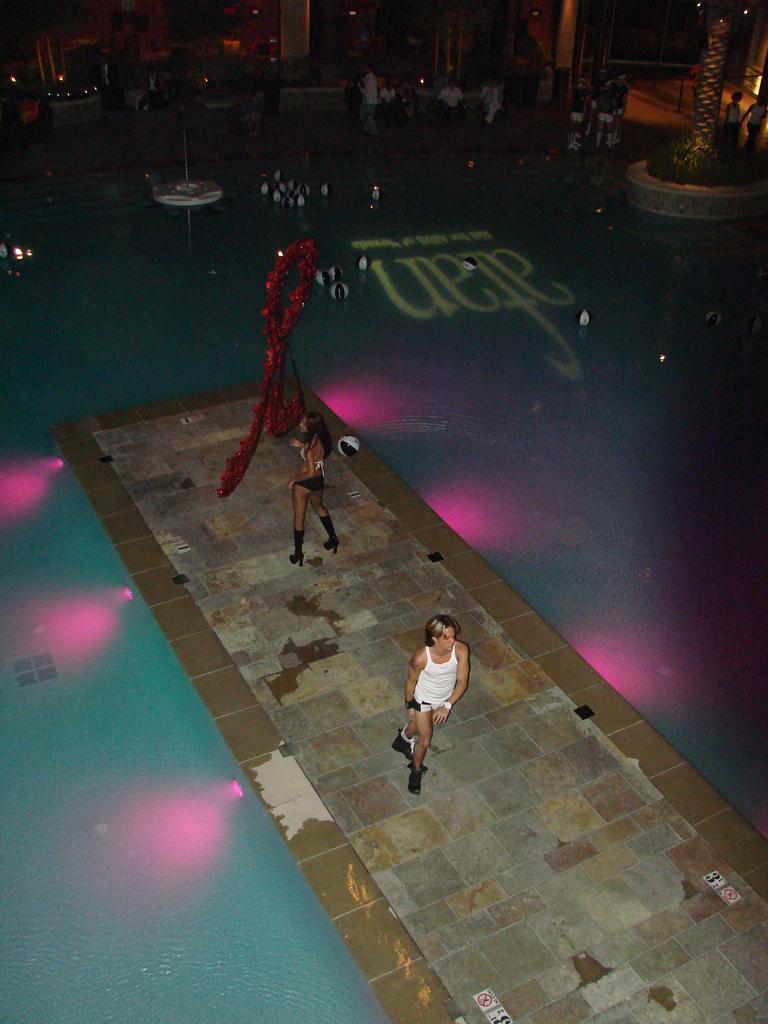Can you describe this image briefly? There are two people in motion and we can see red object and lights. We can see balls above the water. In the background we can see people, tree, plants and lights. 